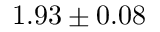Convert formula to latex. <formula><loc_0><loc_0><loc_500><loc_500>1 . 9 3 \pm 0 . 0 8</formula> 